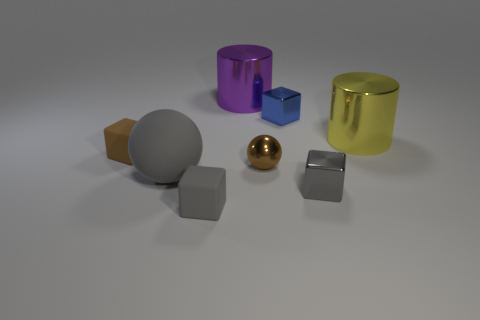Add 1 green rubber cubes. How many objects exist? 9 Subtract all cylinders. How many objects are left? 6 Add 7 yellow things. How many yellow things are left? 8 Add 6 matte balls. How many matte balls exist? 7 Subtract 1 gray spheres. How many objects are left? 7 Subtract all cyan blocks. Subtract all large matte balls. How many objects are left? 7 